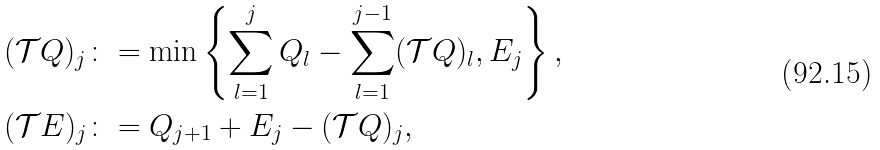Convert formula to latex. <formula><loc_0><loc_0><loc_500><loc_500>( \mathcal { T } Q ) _ { j } & \colon = \min \left \{ \sum _ { l = 1 } ^ { j } Q _ { l } - \sum _ { l = 1 } ^ { j - 1 } ( \mathcal { T } Q ) _ { l } , { E } _ { j } \right \} , \\ ( \mathcal { T } { E } ) _ { j } & \colon = Q _ { j + 1 } + { E } _ { j } - ( \mathcal { T } Q ) _ { j } ,</formula> 